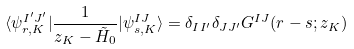<formula> <loc_0><loc_0><loc_500><loc_500>\langle \psi ^ { I ^ { \prime } J ^ { \prime } } _ { r , K } | \frac { 1 } { z _ { K } - \tilde { H } _ { 0 } } | \psi ^ { I J } _ { s , K } \rangle = \delta _ { I I ^ { \prime } } \delta _ { J J ^ { \prime } } G ^ { I J } ( r - s ; z _ { K } )</formula> 